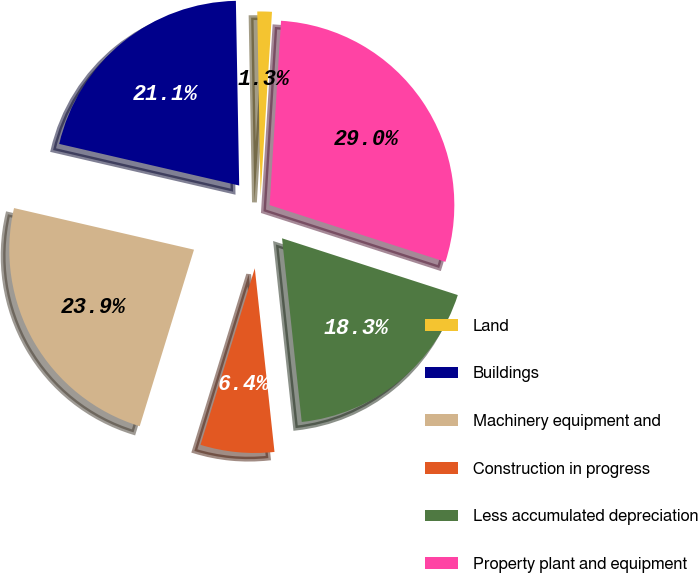Convert chart. <chart><loc_0><loc_0><loc_500><loc_500><pie_chart><fcel>Land<fcel>Buildings<fcel>Machinery equipment and<fcel>Construction in progress<fcel>Less accumulated depreciation<fcel>Property plant and equipment<nl><fcel>1.27%<fcel>21.1%<fcel>23.87%<fcel>6.45%<fcel>18.33%<fcel>28.99%<nl></chart> 